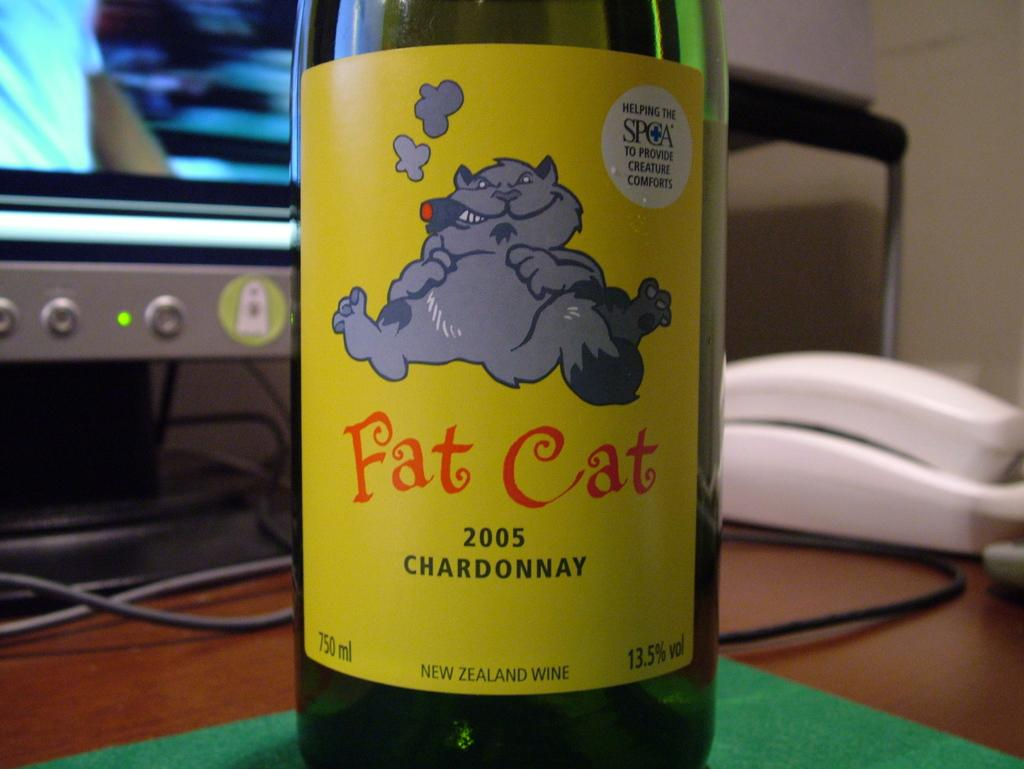What object is located on the table in the foreground of the image? There is a bottle on a table in the foreground of the image. What type of communication device can be seen in the background of the image? In the background of the image, there is a land phone. What electronic device is present in the background of the image? In the background of the image, there is a monitor. What type of wiring is visible in the background of the image? In the background of the image, there are cables. What type of fuel is being used by the beginner in the image? There is no beginner or fuel present in the image. Can you tell me how many kettles are visible in the image? There are no kettles visible in the image. 